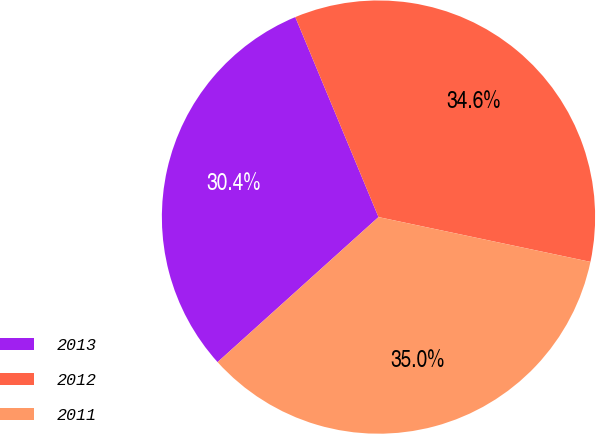Convert chart to OTSL. <chart><loc_0><loc_0><loc_500><loc_500><pie_chart><fcel>2013<fcel>2012<fcel>2011<nl><fcel>30.4%<fcel>34.59%<fcel>35.01%<nl></chart> 